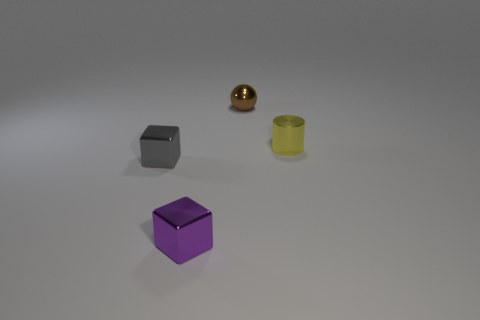Can you describe the lighting in this scene? The lighting in this scene is soft and diffused, providing even illumination with minimal harsh shadows. It seems like there's a light source above the center of the scene based on the soft shadows each object casts. 